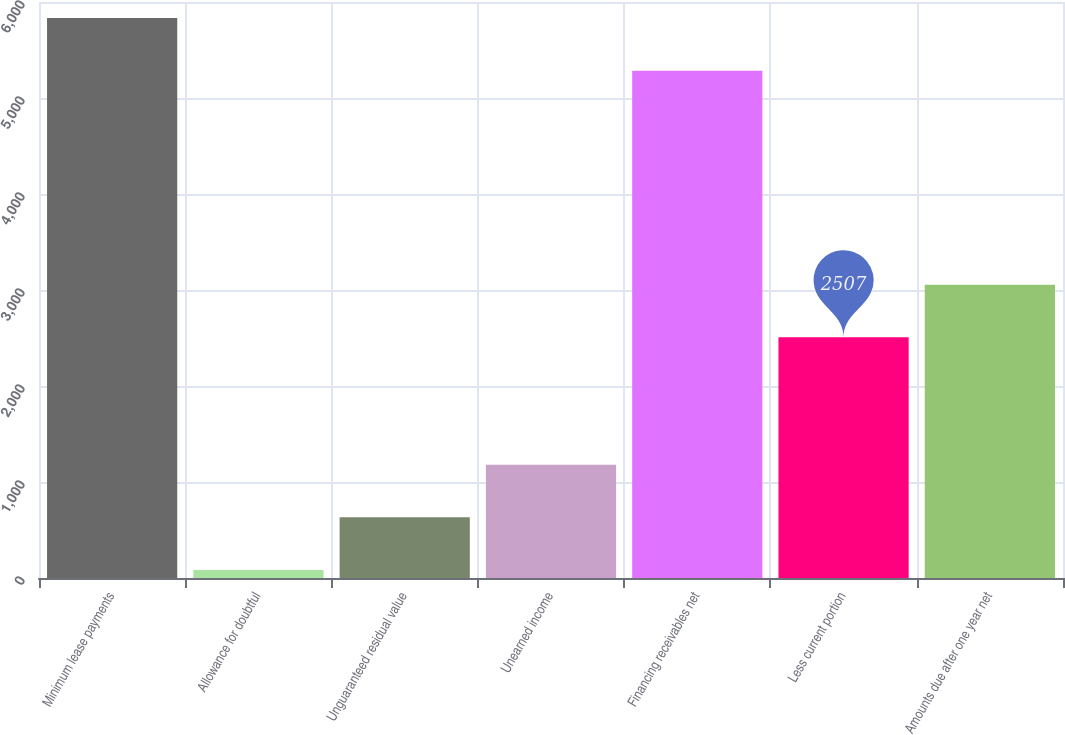<chart> <loc_0><loc_0><loc_500><loc_500><bar_chart><fcel>Minimum lease payments<fcel>Allowance for doubtful<fcel>Unguaranteed residual value<fcel>Unearned income<fcel>Financing receivables net<fcel>Less current portion<fcel>Amounts due after one year net<nl><fcel>5833.4<fcel>84<fcel>632.4<fcel>1180.8<fcel>5285<fcel>2507<fcel>3055.4<nl></chart> 